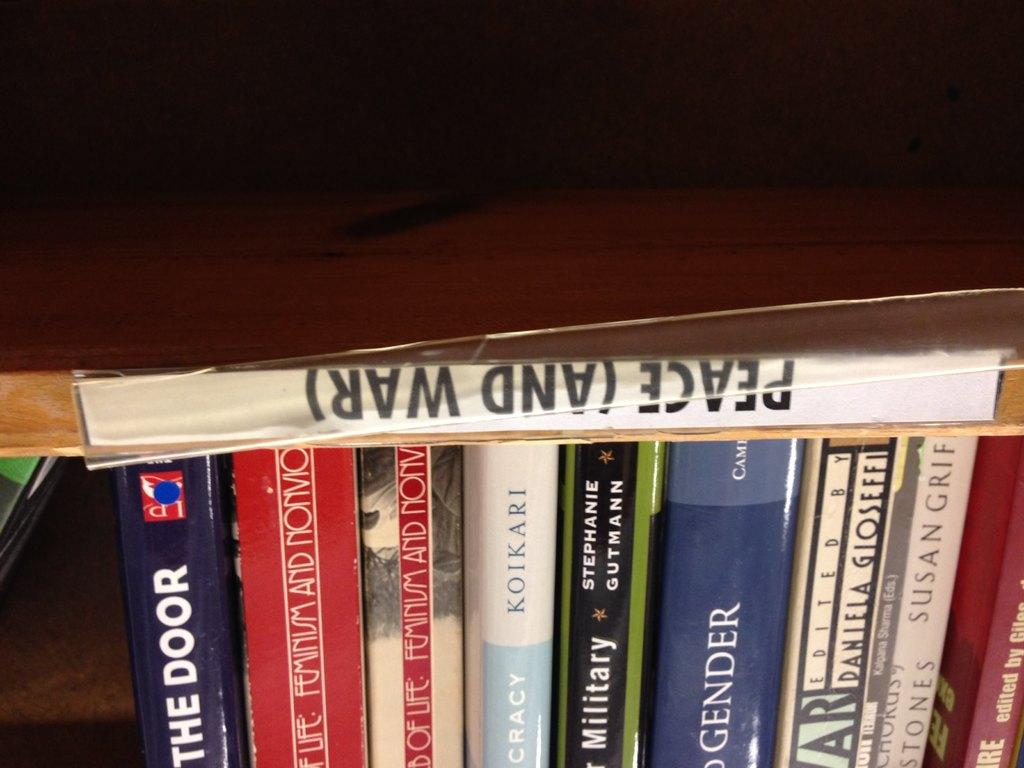<image>
Summarize the visual content of the image. A group of books that are together under the section called Peace (and war). 